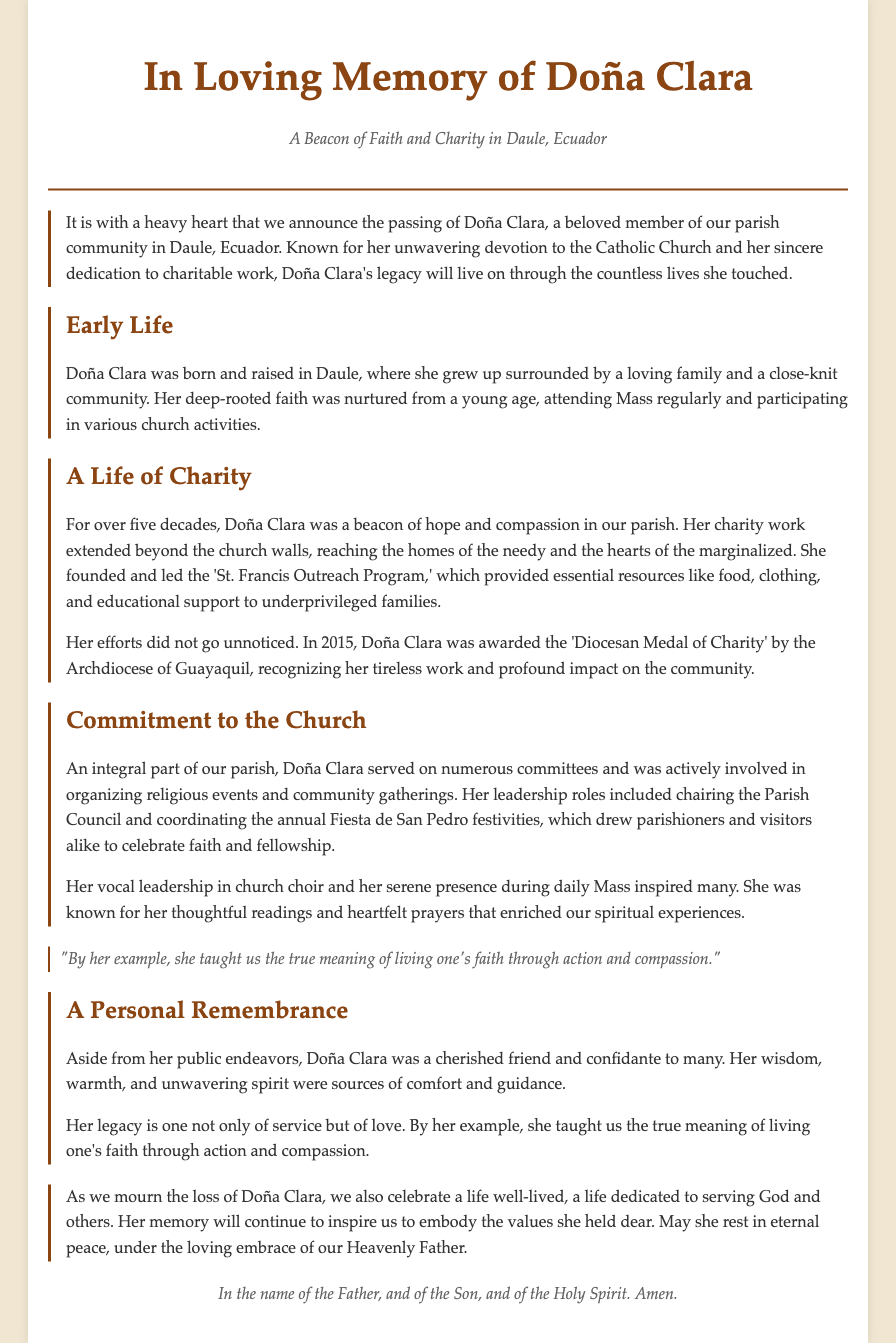What is the full name of the individual being memorialized? The full name mentioned in the document is Doña Clara.
Answer: Doña Clara What charity program did Doña Clara found? The document states that Doña Clara founded the 'St. Francis Outreach Program.'
Answer: St. Francis Outreach Program What year did Doña Clara receive the 'Diocesan Medal of Charity'? According to the document, Doña Clara received the award in 2015.
Answer: 2015 What role did Doña Clara play in the church choir? The document notes that she had a vocal leadership role in the church choir.
Answer: Vocal leader How many decades did Doña Clara dedicate to charity work? The document mentions that she worked in charity for over five decades.
Answer: Five decades What was the attitude of Doña Clara towards her faith? The document emphasizes her unwavering devotion to the Catholic Church.
Answer: Unwavering devotion Which event did Doña Clara coordinate annually? According to the document, she coordinated the annual Fiesta de San Pedro.
Answer: Fiesta de San Pedro What award did Doña Clara receive from the Archdiocese of Guayaquil? The document mentions that she was awarded the 'Diocesan Medal of Charity.'
Answer: Diocesan Medal of Charity What is mentioned as a personal trait of Doña Clara? The document describes her wisdom, warmth, and unwavering spirit as personal traits.
Answer: Wisdom and warmth 